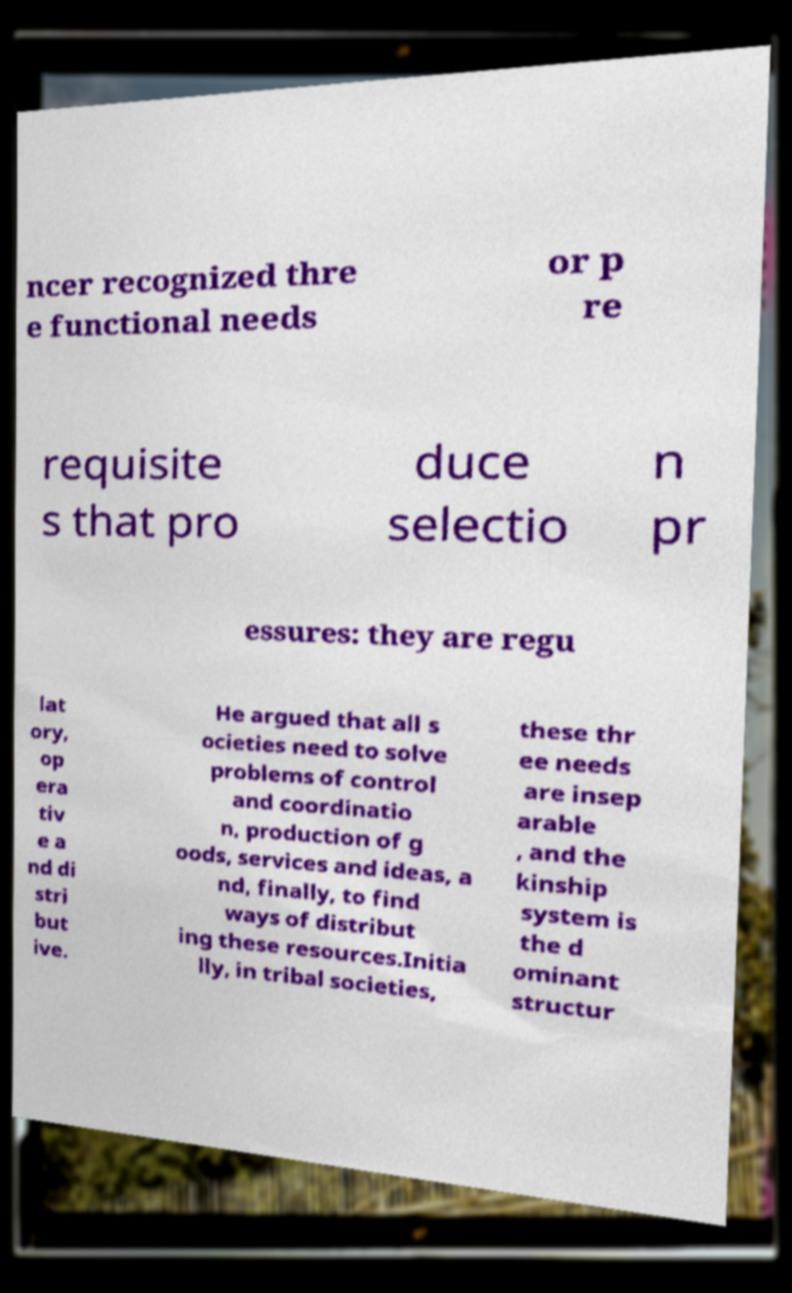Could you assist in decoding the text presented in this image and type it out clearly? ncer recognized thre e functional needs or p re requisite s that pro duce selectio n pr essures: they are regu lat ory, op era tiv e a nd di stri but ive. He argued that all s ocieties need to solve problems of control and coordinatio n, production of g oods, services and ideas, a nd, finally, to find ways of distribut ing these resources.Initia lly, in tribal societies, these thr ee needs are insep arable , and the kinship system is the d ominant structur 